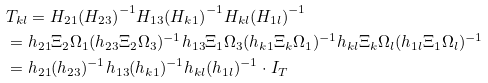Convert formula to latex. <formula><loc_0><loc_0><loc_500><loc_500>& T _ { k l } = H _ { 2 1 } { ( H _ { 2 3 } ) } ^ { - 1 } H _ { 1 3 } { ( H _ { k 1 } ) } ^ { - 1 } H _ { k l } { ( H _ { 1 l } ) } ^ { - 1 } \\ & = h _ { 2 1 } \Xi _ { 2 } \Omega _ { 1 } ( h _ { 2 3 } \Xi _ { 2 } \Omega _ { 3 } ) ^ { - 1 } h _ { 1 3 } \Xi _ { 1 } \Omega _ { 3 } ( h _ { k 1 } \Xi _ { k } \Omega _ { 1 } ) ^ { - 1 } h _ { k l } \Xi _ { k } \Omega _ { l } ( h _ { 1 l } \Xi _ { 1 } \Omega _ { l } ) ^ { - 1 } \\ & = h _ { 2 1 } ( h _ { 2 3 } ) ^ { - 1 } h _ { 1 3 } ( h _ { k 1 } ) ^ { - 1 } h _ { k l } ( h _ { 1 l } ) ^ { - 1 } \cdot I _ { T }</formula> 